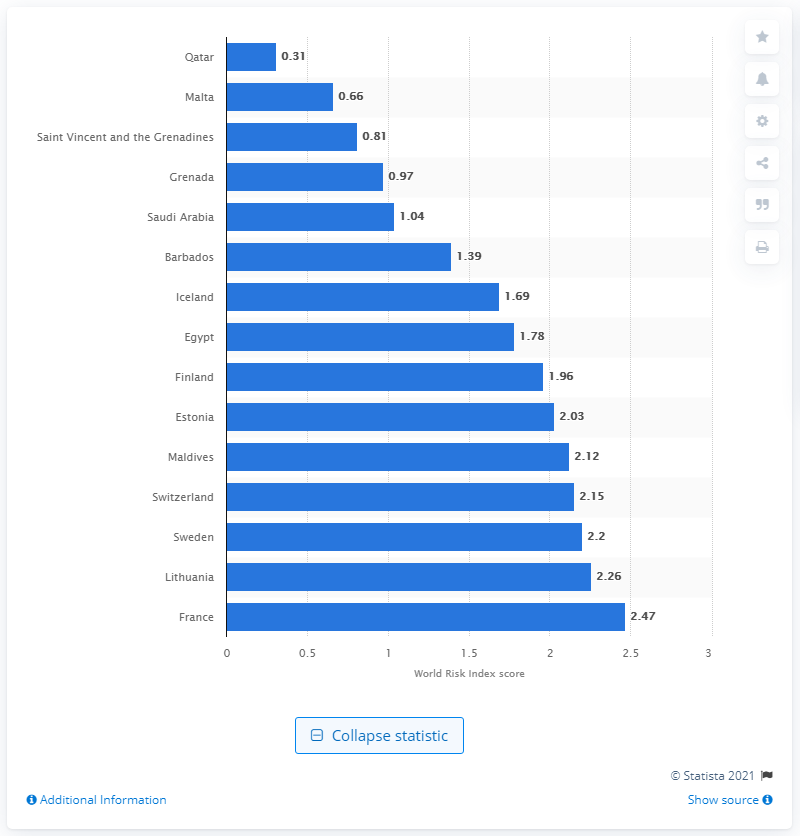Draw attention to some important aspects in this diagram. In 2020, Qatar's index value was 0.31. 